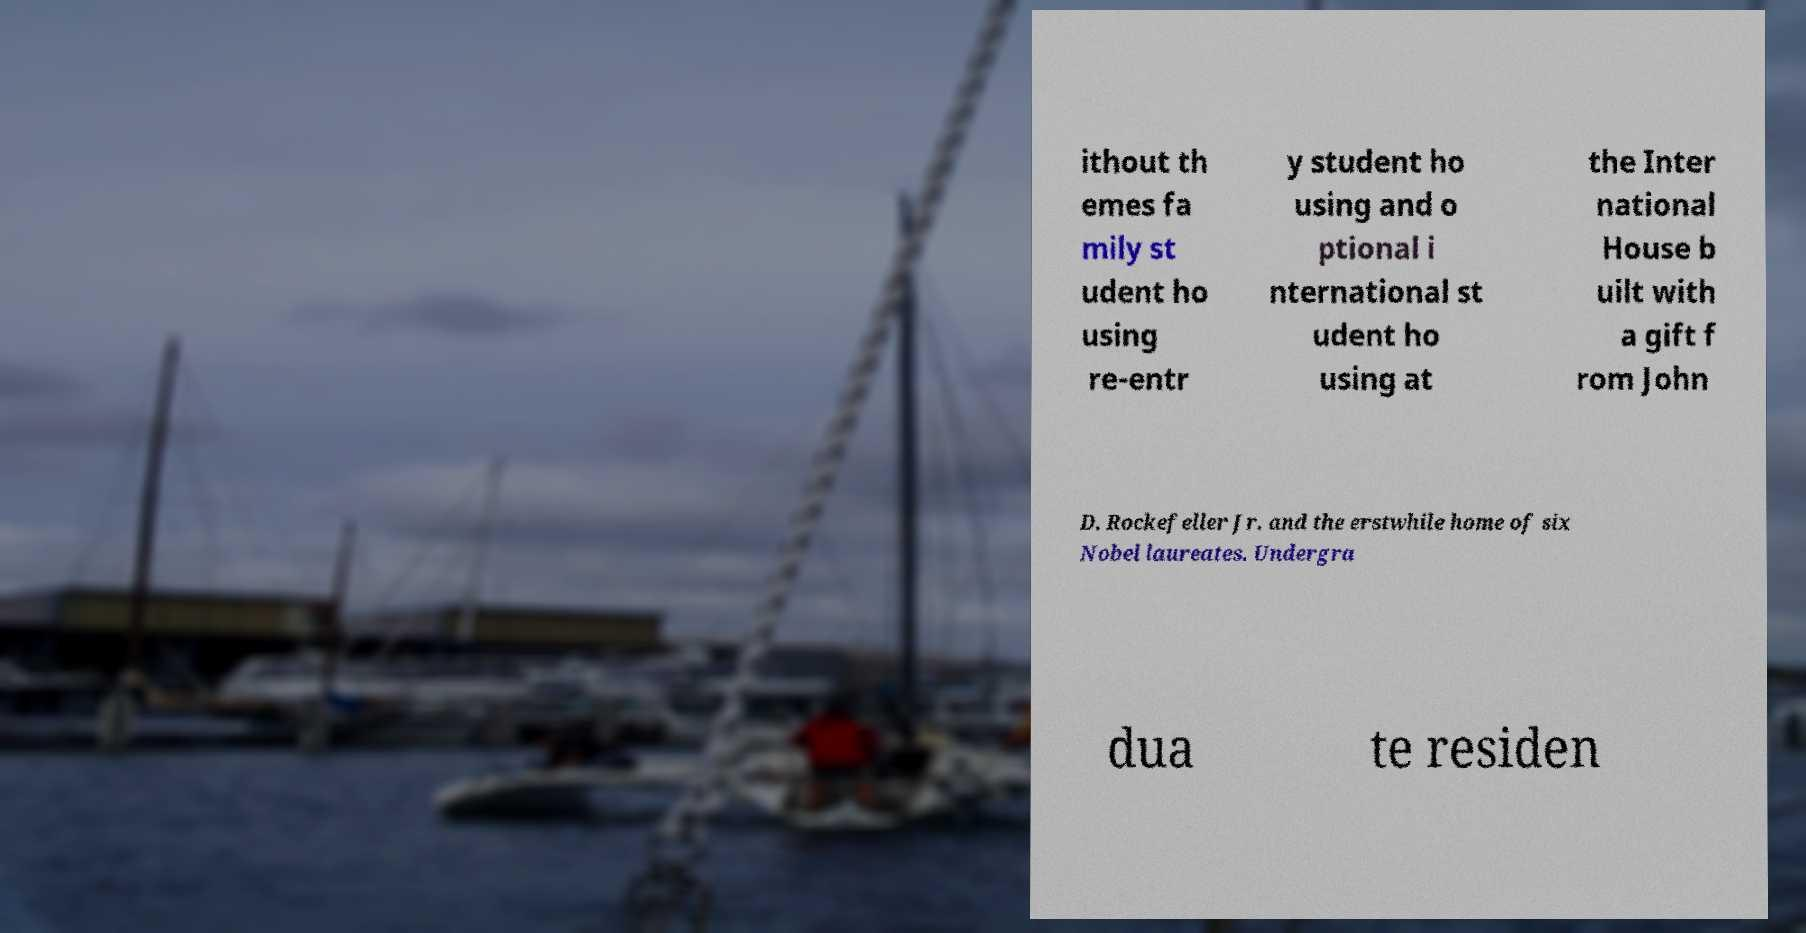Can you read and provide the text displayed in the image?This photo seems to have some interesting text. Can you extract and type it out for me? ithout th emes fa mily st udent ho using re-entr y student ho using and o ptional i nternational st udent ho using at the Inter national House b uilt with a gift f rom John D. Rockefeller Jr. and the erstwhile home of six Nobel laureates. Undergra dua te residen 